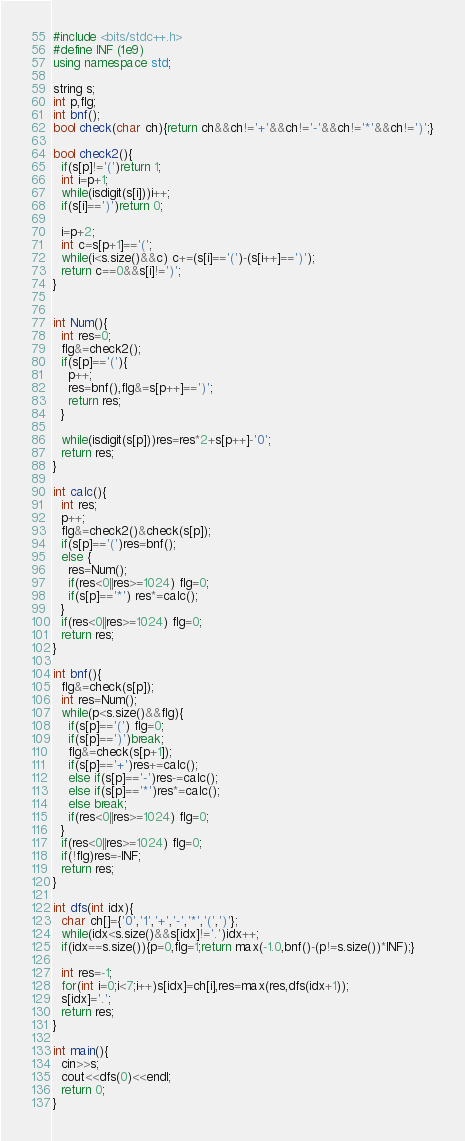<code> <loc_0><loc_0><loc_500><loc_500><_C++_>#include <bits/stdc++.h>
#define INF (1e9)
using namespace std;

string s;
int p,flg;
int bnf();
bool check(char ch){return ch&&ch!='+'&&ch!='-'&&ch!='*'&&ch!=')';}

bool check2(){
  if(s[p]!='(')return 1;
  int i=p+1;
  while(isdigit(s[i]))i++;
  if(s[i]==')')return 0;
  
  i=p+2;
  int c=s[p+1]=='(';
  while(i<s.size()&&c) c+=(s[i]=='(')-(s[i++]==')');
  return c==0&&s[i]!=')';
}


int Num(){
  int res=0;
  flg&=check2();
  if(s[p]=='('){
    p++;
    res=bnf(),flg&=s[p++]==')';
    return res;
  }

  while(isdigit(s[p]))res=res*2+s[p++]-'0';
  return res;
}

int calc(){
  int res;
  p++;
  flg&=check2()&check(s[p]);
  if(s[p]=='(')res=bnf();
  else {
    res=Num();
    if(res<0||res>=1024) flg=0;
    if(s[p]=='*') res*=calc();
  }
  if(res<0||res>=1024) flg=0;
  return res;
}

int bnf(){
  flg&=check(s[p]);
  int res=Num();
  while(p<s.size()&&flg){
    if(s[p]=='(') flg=0;
    if(s[p]==')')break;
    flg&=check(s[p+1]);
    if(s[p]=='+')res+=calc();
    else if(s[p]=='-')res-=calc();
    else if(s[p]=='*')res*=calc();
    else break;
    if(res<0||res>=1024) flg=0;
  }
  if(res<0||res>=1024) flg=0;
  if(!flg)res=-INF;
  return res;
}

int dfs(int idx){
  char ch[]={'0','1','+','-','*','(',')'};
  while(idx<s.size()&&s[idx]!='.')idx++;
  if(idx==s.size()){p=0,flg=1;return max(-1.0,bnf()-(p!=s.size())*INF);}

  int res=-1;
  for(int i=0;i<7;i++)s[idx]=ch[i],res=max(res,dfs(idx+1));
  s[idx]='.';
  return res;
}

int main(){
  cin>>s;
  cout<<dfs(0)<<endl;
  return 0;
}</code> 